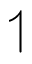Convert formula to latex. <formula><loc_0><loc_0><loc_500><loc_500>\upharpoonleft</formula> 